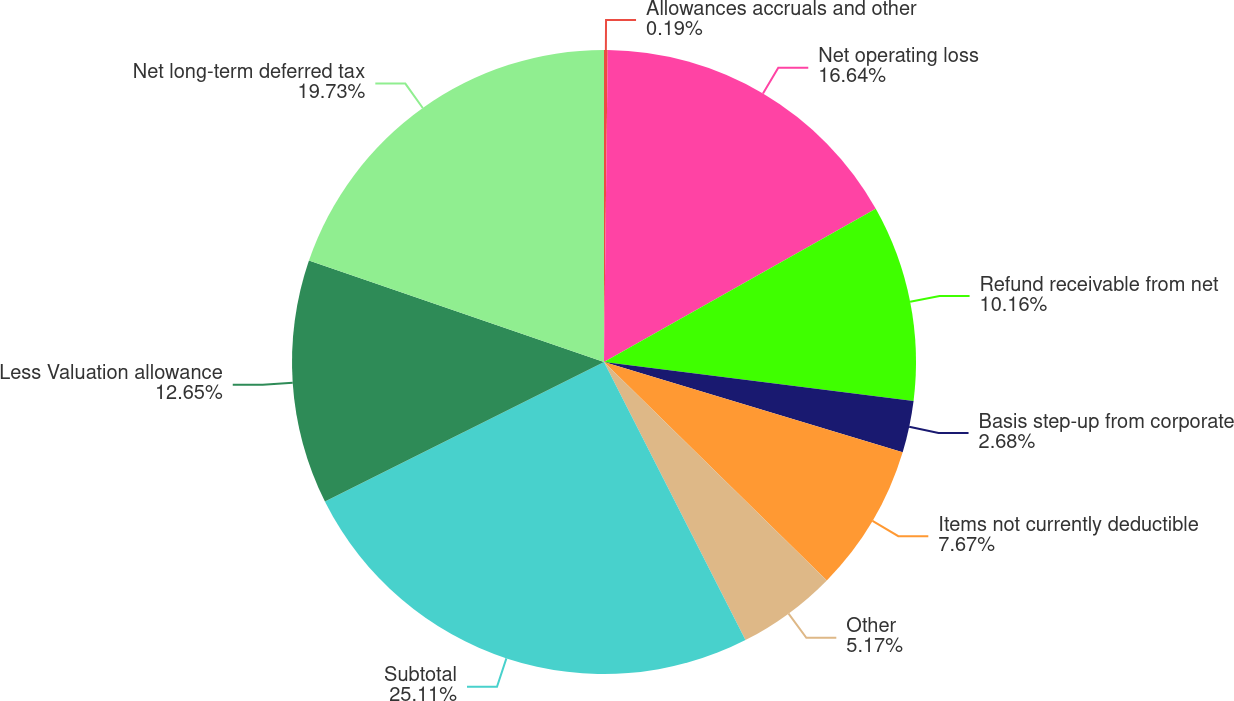Convert chart. <chart><loc_0><loc_0><loc_500><loc_500><pie_chart><fcel>Allowances accruals and other<fcel>Net operating loss<fcel>Refund receivable from net<fcel>Basis step-up from corporate<fcel>Items not currently deductible<fcel>Other<fcel>Subtotal<fcel>Less Valuation allowance<fcel>Net long-term deferred tax<nl><fcel>0.19%<fcel>16.64%<fcel>10.16%<fcel>2.68%<fcel>7.67%<fcel>5.17%<fcel>25.11%<fcel>12.65%<fcel>19.73%<nl></chart> 